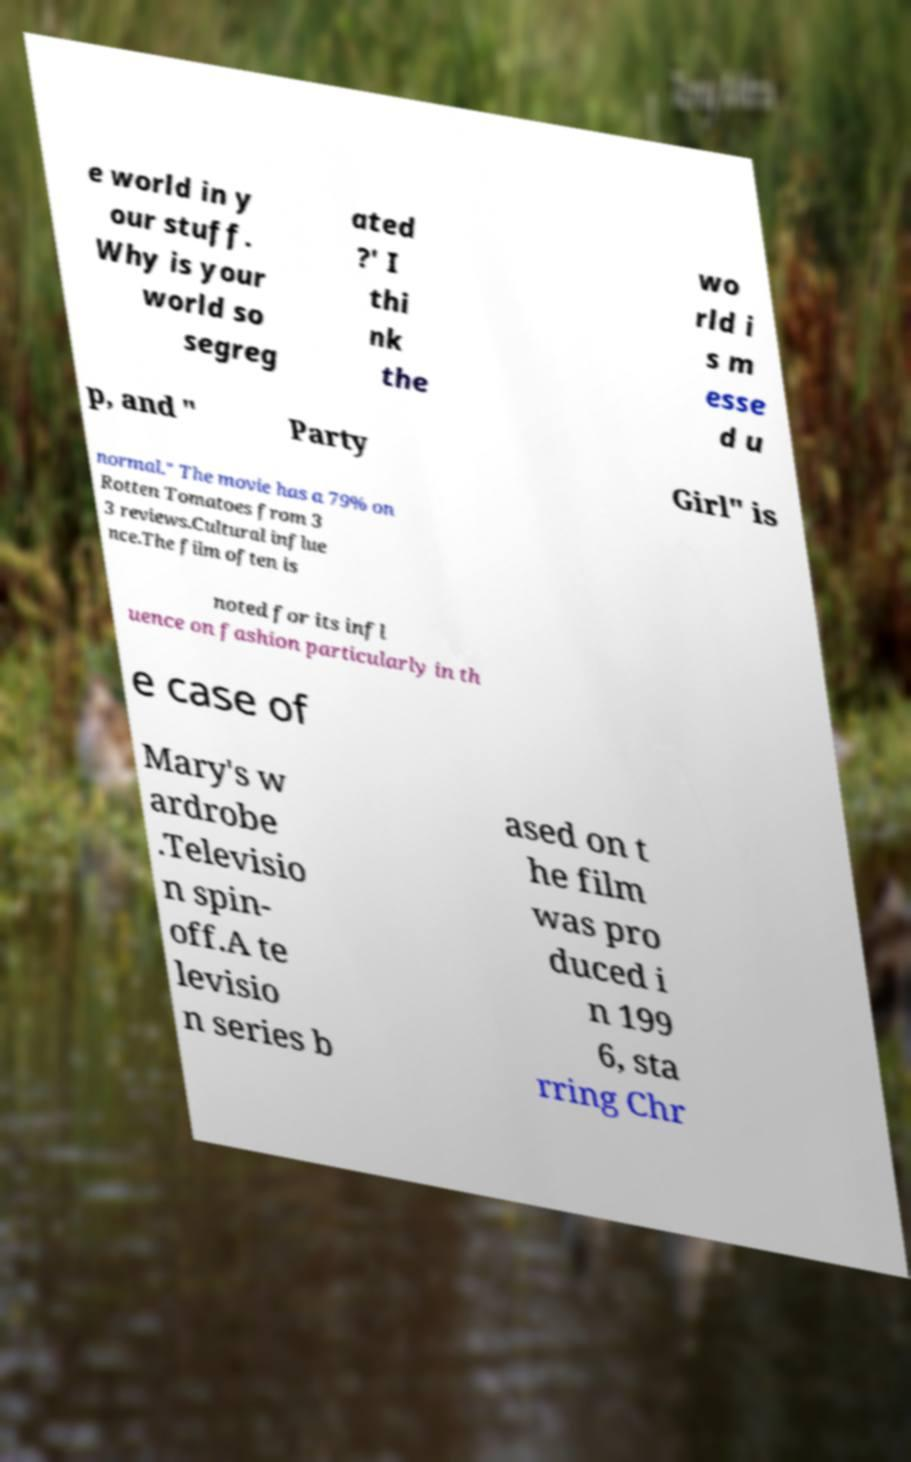Could you extract and type out the text from this image? e world in y our stuff. Why is your world so segreg ated ?' I thi nk the wo rld i s m esse d u p, and " Party Girl" is normal." The movie has a 79% on Rotten Tomatoes from 3 3 reviews.Cultural influe nce.The film often is noted for its infl uence on fashion particularly in th e case of Mary's w ardrobe .Televisio n spin- off.A te levisio n series b ased on t he film was pro duced i n 199 6, sta rring Chr 